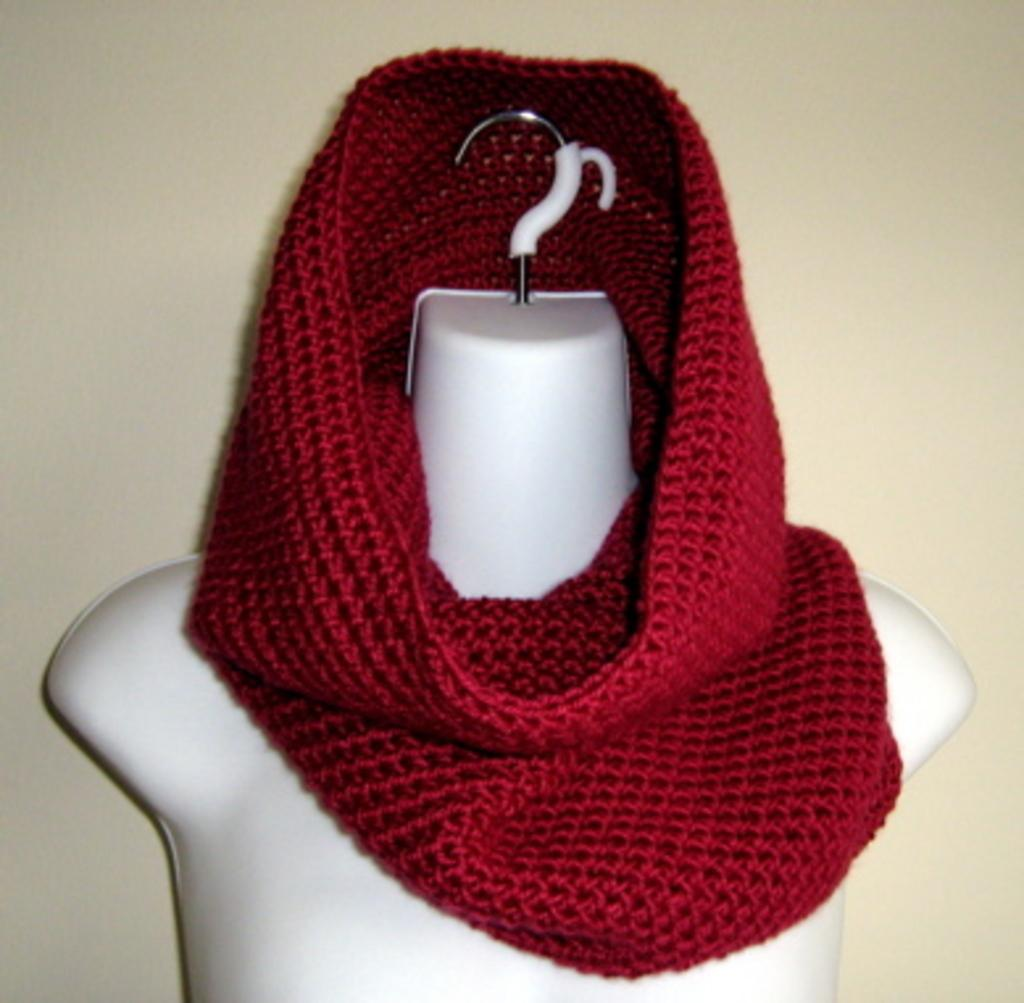What is the color of the stole in the image? The stole in the image is red. Where is the stole placed in the image? The stole is on a dummy. What can be seen in the background of the image? There is a wall visible in the image. How many muscles can be seen on the foot in the image? There is no foot visible in the image, and therefore no muscles can be seen. 